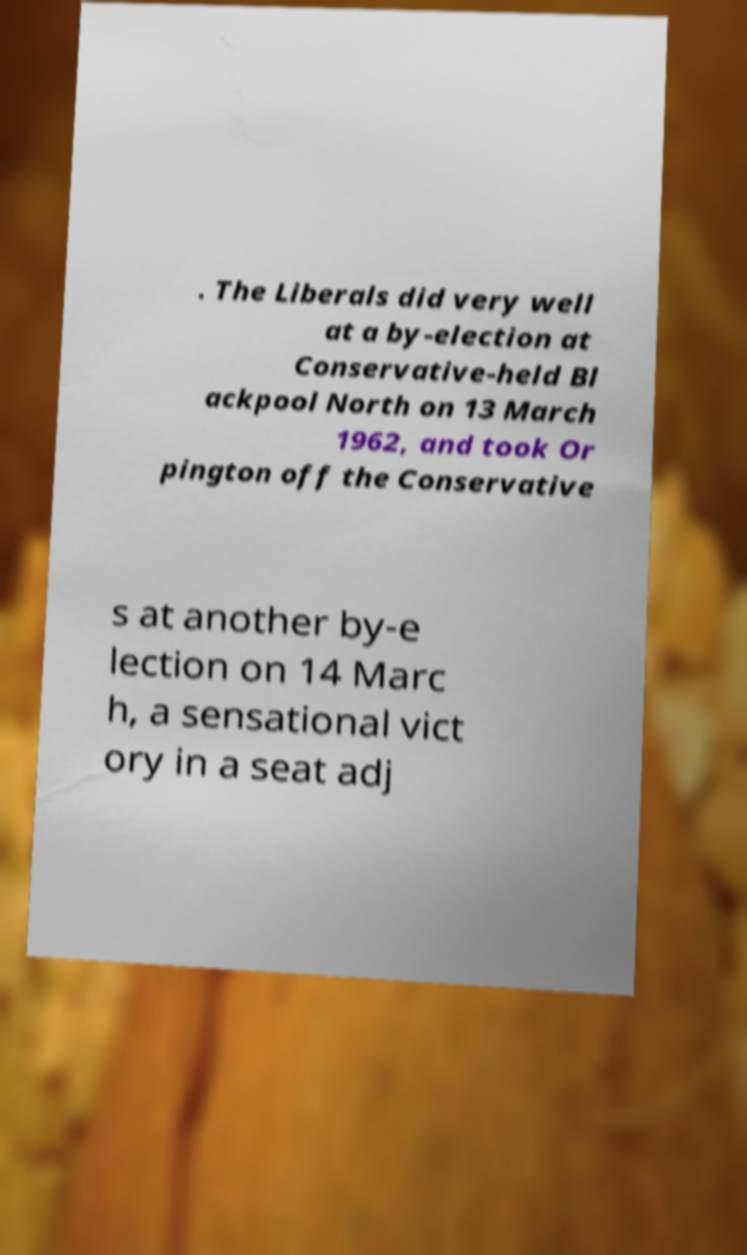Could you assist in decoding the text presented in this image and type it out clearly? . The Liberals did very well at a by-election at Conservative-held Bl ackpool North on 13 March 1962, and took Or pington off the Conservative s at another by-e lection on 14 Marc h, a sensational vict ory in a seat adj 